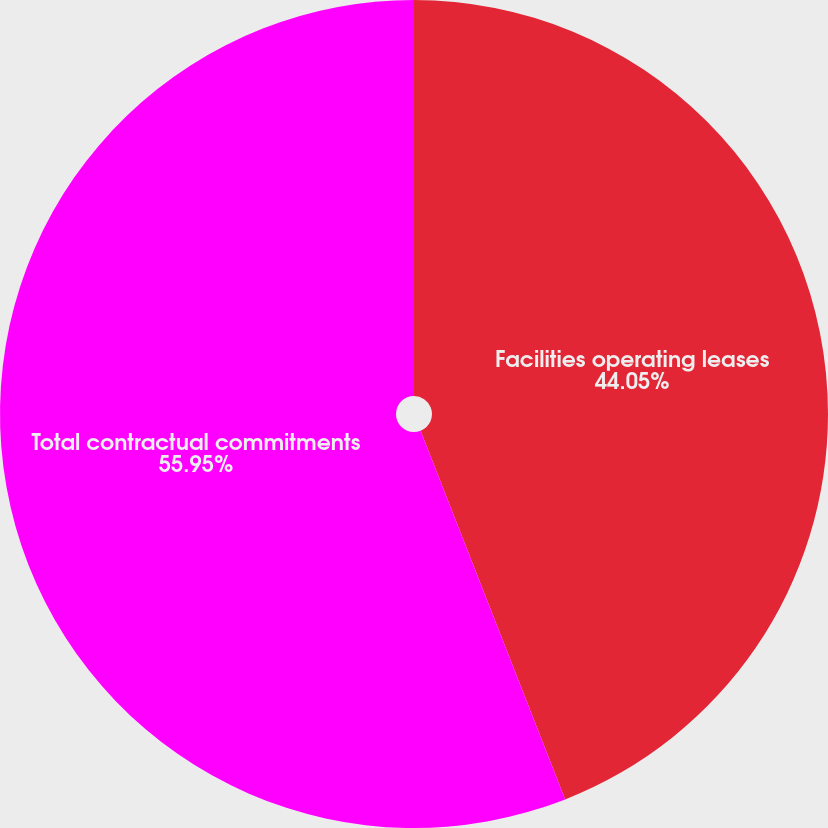<chart> <loc_0><loc_0><loc_500><loc_500><pie_chart><fcel>Facilities operating leases<fcel>Total contractual commitments<nl><fcel>44.05%<fcel>55.95%<nl></chart> 